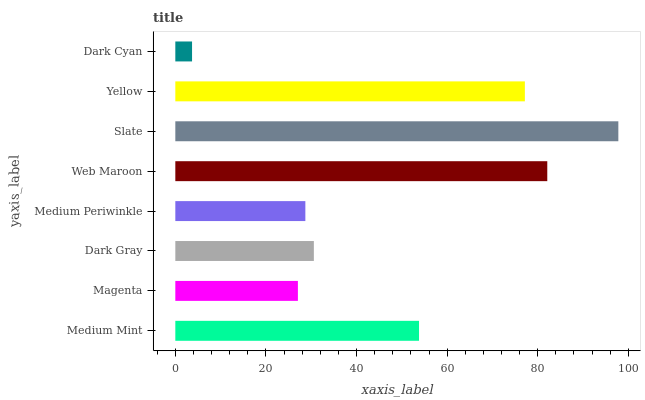Is Dark Cyan the minimum?
Answer yes or no. Yes. Is Slate the maximum?
Answer yes or no. Yes. Is Magenta the minimum?
Answer yes or no. No. Is Magenta the maximum?
Answer yes or no. No. Is Medium Mint greater than Magenta?
Answer yes or no. Yes. Is Magenta less than Medium Mint?
Answer yes or no. Yes. Is Magenta greater than Medium Mint?
Answer yes or no. No. Is Medium Mint less than Magenta?
Answer yes or no. No. Is Medium Mint the high median?
Answer yes or no. Yes. Is Dark Gray the low median?
Answer yes or no. Yes. Is Medium Periwinkle the high median?
Answer yes or no. No. Is Web Maroon the low median?
Answer yes or no. No. 